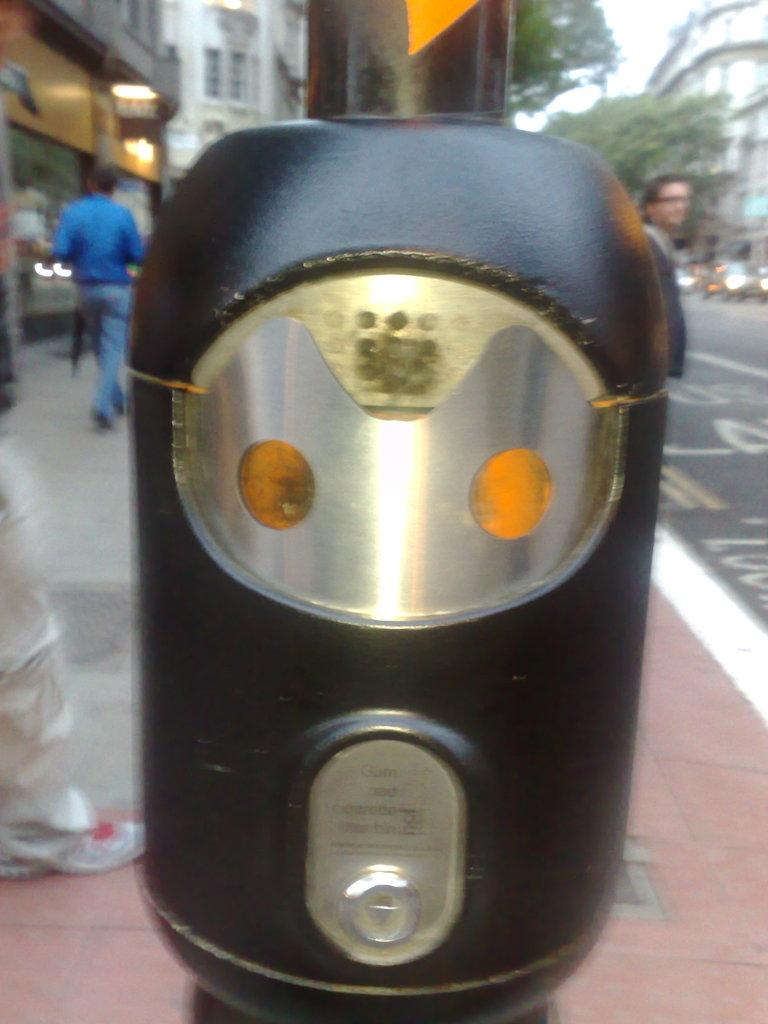What is the color of the object in the image? The object in the image is black. What can be seen in the background of the image? In the background of the image, there are people, a road, a walkway, trees, buildings, vehicles, and lights. Can you describe the setting of the image? The image appears to be set in an urban environment with buildings, roads, and vehicles. Where is the cactus located in the image? There is no cactus present in the image. How does the basket move around in the image? There is no basket present in the image, so it cannot move around. 